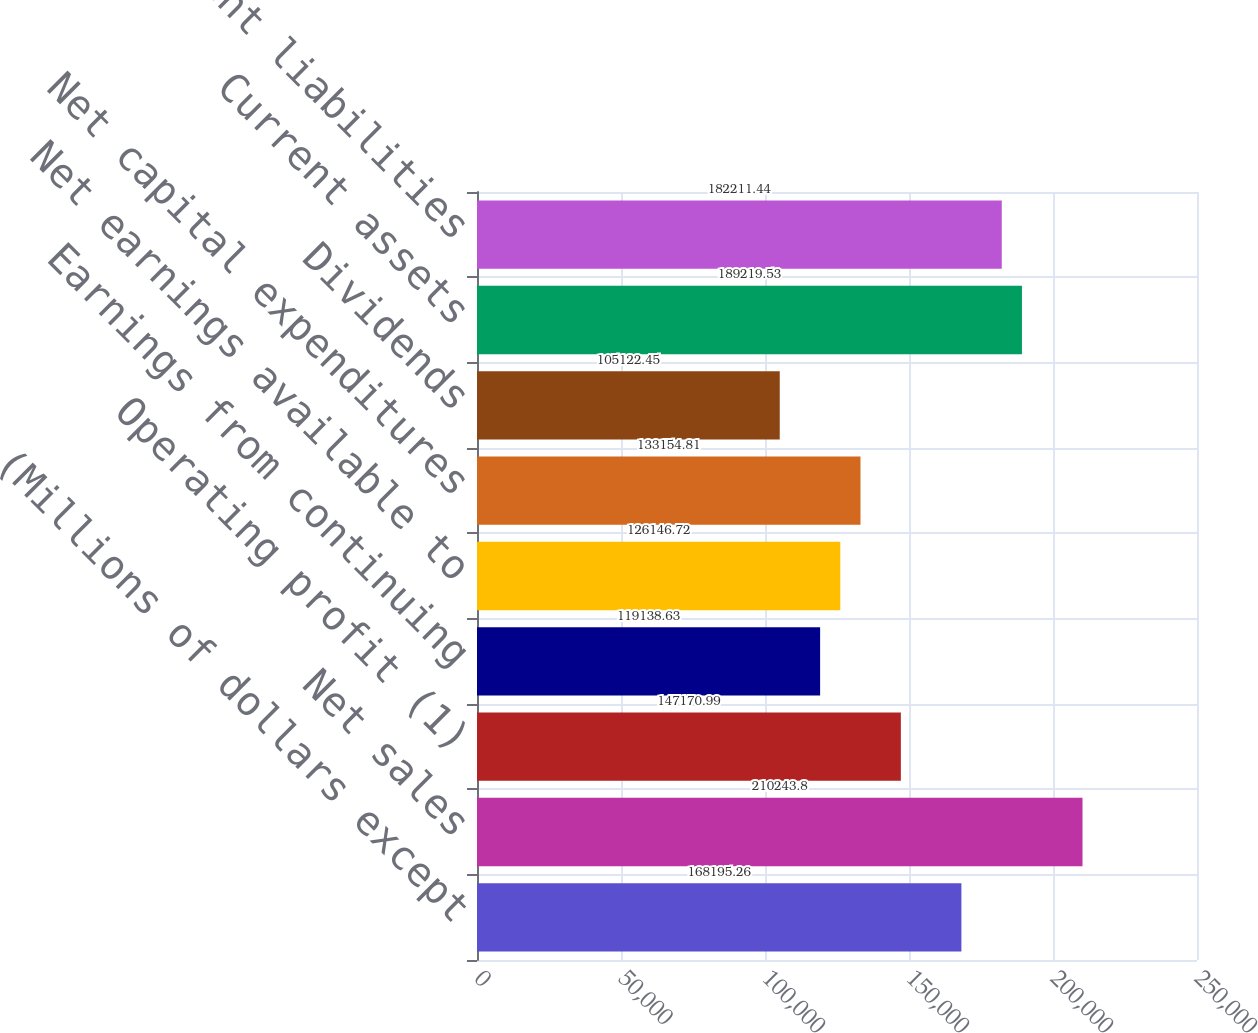<chart> <loc_0><loc_0><loc_500><loc_500><bar_chart><fcel>(Millions of dollars except<fcel>Net sales<fcel>Operating profit (1)<fcel>Earnings from continuing<fcel>Net earnings available to<fcel>Net capital expenditures<fcel>Dividends<fcel>Current assets<fcel>Current liabilities<nl><fcel>168195<fcel>210244<fcel>147171<fcel>119139<fcel>126147<fcel>133155<fcel>105122<fcel>189220<fcel>182211<nl></chart> 